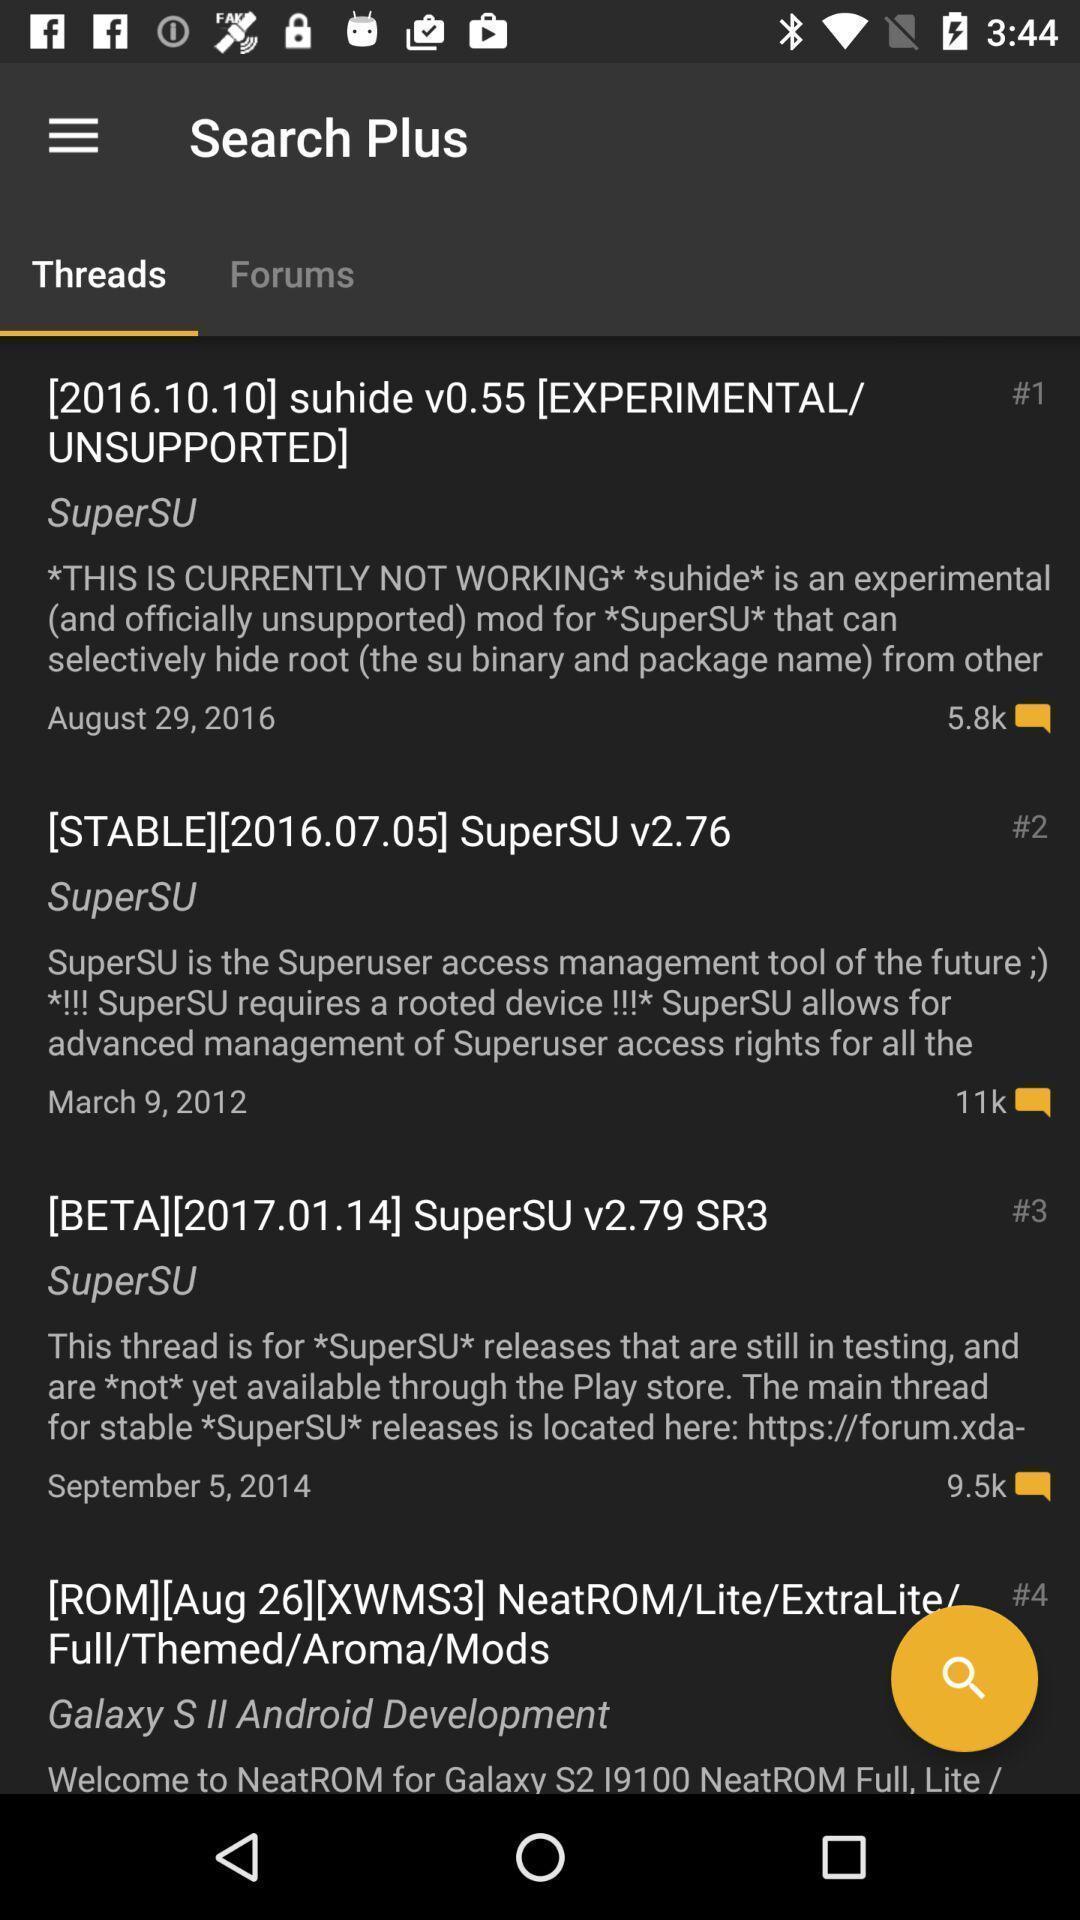Tell me what you see in this picture. Search page for searching threads and forums. 